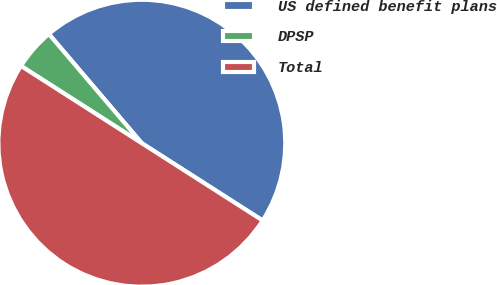Convert chart to OTSL. <chart><loc_0><loc_0><loc_500><loc_500><pie_chart><fcel>US defined benefit plans<fcel>DPSP<fcel>Total<nl><fcel>45.28%<fcel>4.72%<fcel>50.0%<nl></chart> 